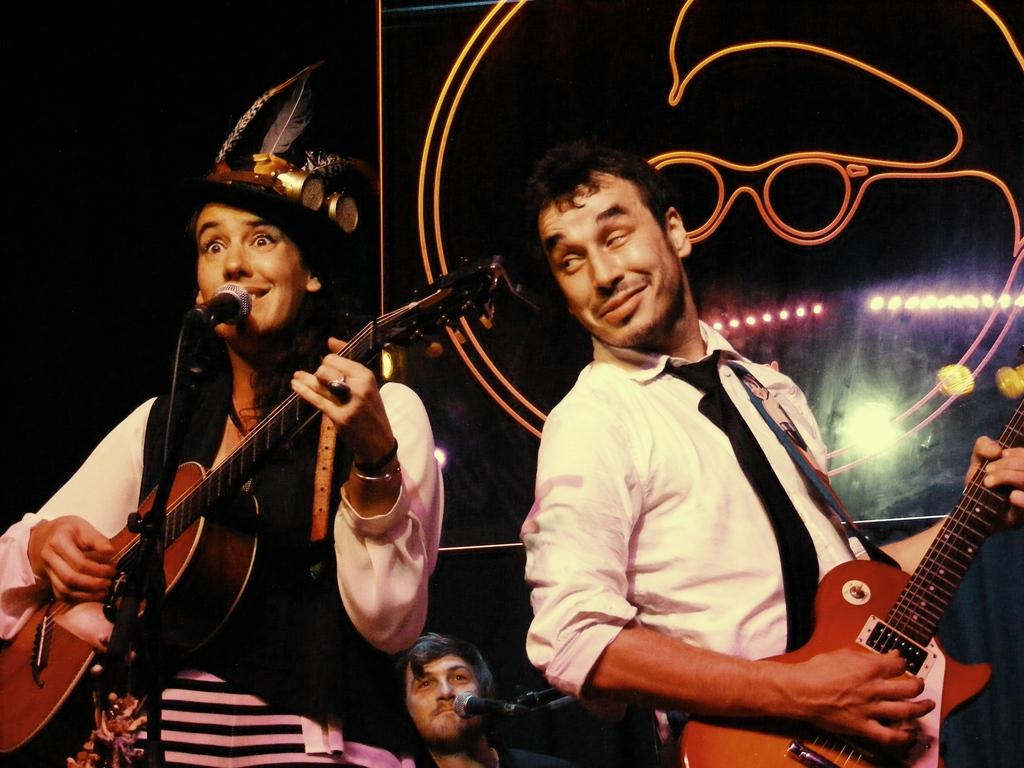How many people are in the image? There are two people in the image. What are the two people doing? The two people are standing and holding guitars. What expressions do the people have on their faces? The people have smiles on their faces. Can you describe the background of the image? There is a person in the background of the image, and there are microphones visible. What type of weather can be seen in the image? There is no weather visible in the image, as it is an indoor setting with no windows or outdoor elements. 